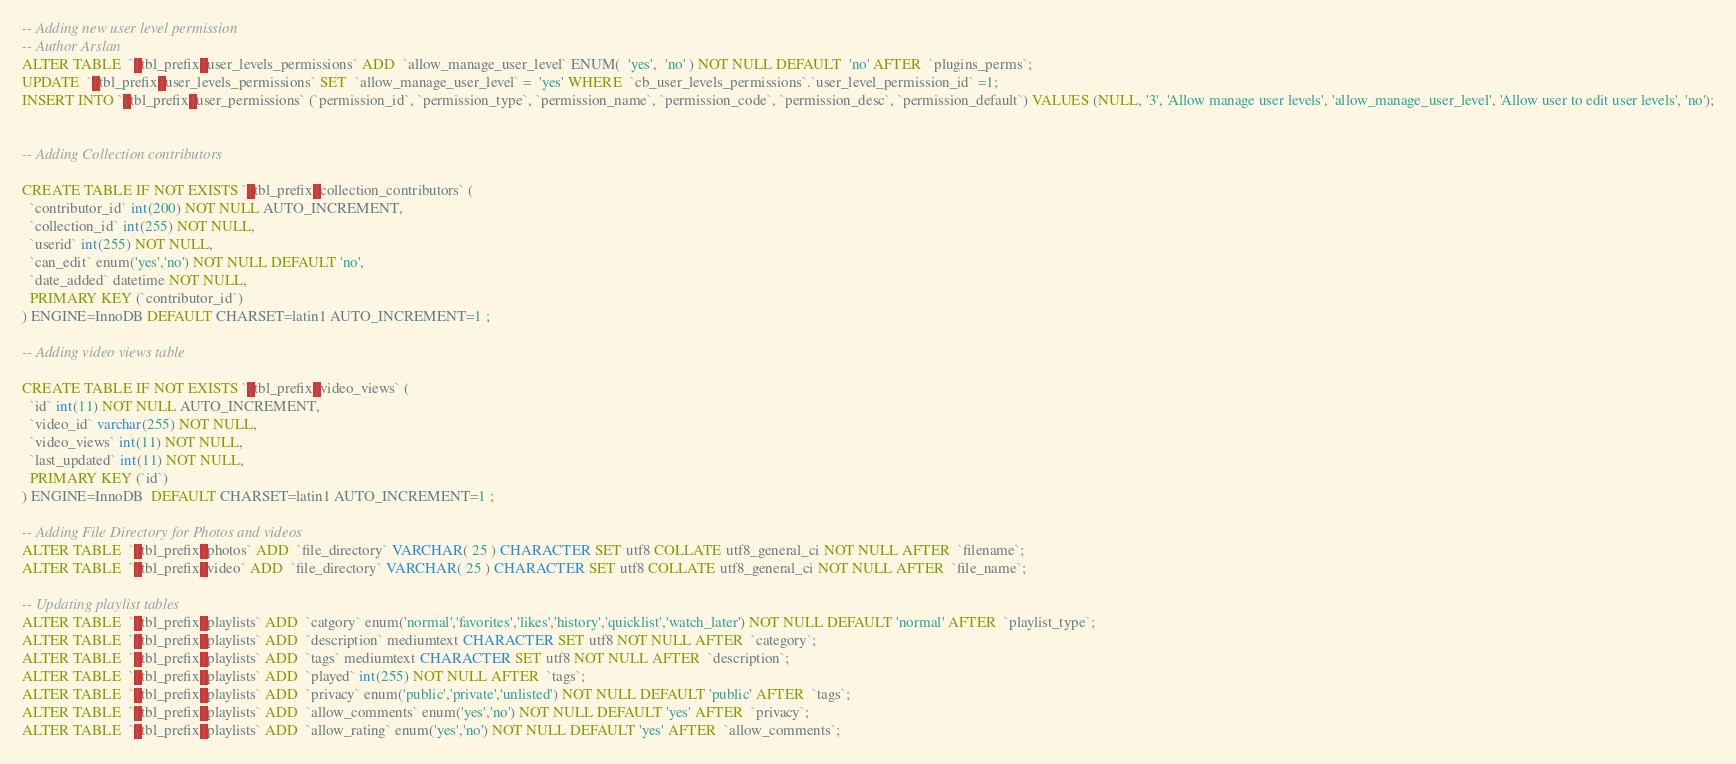Convert code to text. <code><loc_0><loc_0><loc_500><loc_500><_SQL_>-- Adding new user level permission
-- Author Arslan
ALTER TABLE  `{tbl_prefix}user_levels_permissions` ADD  `allow_manage_user_level` ENUM(  'yes',  'no' ) NOT NULL DEFAULT  'no' AFTER  `plugins_perms`;
UPDATE  `{tbl_prefix}user_levels_permissions` SET  `allow_manage_user_level` =  'yes' WHERE  `cb_user_levels_permissions`.`user_level_permission_id` =1;
INSERT INTO `{tbl_prefix}user_permissions` (`permission_id`, `permission_type`, `permission_name`, `permission_code`, `permission_desc`, `permission_default`) VALUES (NULL, '3', 'Allow manage user levels', 'allow_manage_user_level', 'Allow user to edit user levels', 'no');


-- Adding Collection contributors

CREATE TABLE IF NOT EXISTS `{tbl_prefix}collection_contributors` (
  `contributor_id` int(200) NOT NULL AUTO_INCREMENT,
  `collection_id` int(255) NOT NULL,
  `userid` int(255) NOT NULL,
  `can_edit` enum('yes','no') NOT NULL DEFAULT 'no',
  `date_added` datetime NOT NULL,
  PRIMARY KEY (`contributor_id`)
) ENGINE=InnoDB DEFAULT CHARSET=latin1 AUTO_INCREMENT=1 ;

-- Adding video views table

CREATE TABLE IF NOT EXISTS `{tbl_prefix}video_views` (
  `id` int(11) NOT NULL AUTO_INCREMENT,
  `video_id` varchar(255) NOT NULL,
  `video_views` int(11) NOT NULL,
  `last_updated` int(11) NOT NULL,
  PRIMARY KEY (`id`)
) ENGINE=InnoDB  DEFAULT CHARSET=latin1 AUTO_INCREMENT=1 ;

-- Adding File Directory for Photos and videos
ALTER TABLE  `{tbl_prefix}photos` ADD  `file_directory` VARCHAR( 25 ) CHARACTER SET utf8 COLLATE utf8_general_ci NOT NULL AFTER  `filename`;
ALTER TABLE  `{tbl_prefix}video` ADD  `file_directory` VARCHAR( 25 ) CHARACTER SET utf8 COLLATE utf8_general_ci NOT NULL AFTER  `file_name`;

-- Updating playlist tables
ALTER TABLE  `{tbl_prefix}playlists` ADD  `catgory` enum('normal','favorites','likes','history','quicklist','watch_later') NOT NULL DEFAULT 'normal' AFTER  `playlist_type`;
ALTER TABLE  `{tbl_prefix}playlists` ADD  `description` mediumtext CHARACTER SET utf8 NOT NULL AFTER  `category`;
ALTER TABLE  `{tbl_prefix}playlists` ADD  `tags` mediumtext CHARACTER SET utf8 NOT NULL AFTER  `description`;
ALTER TABLE  `{tbl_prefix}playlists` ADD  `played` int(255) NOT NULL AFTER  `tags`;
ALTER TABLE  `{tbl_prefix}playlists` ADD  `privacy` enum('public','private','unlisted') NOT NULL DEFAULT 'public' AFTER  `tags`;
ALTER TABLE  `{tbl_prefix}playlists` ADD  `allow_comments` enum('yes','no') NOT NULL DEFAULT 'yes' AFTER  `privacy`;
ALTER TABLE  `{tbl_prefix}playlists` ADD  `allow_rating` enum('yes','no') NOT NULL DEFAULT 'yes' AFTER  `allow_comments`;</code> 